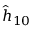<formula> <loc_0><loc_0><loc_500><loc_500>\hat { h } _ { 1 0 }</formula> 